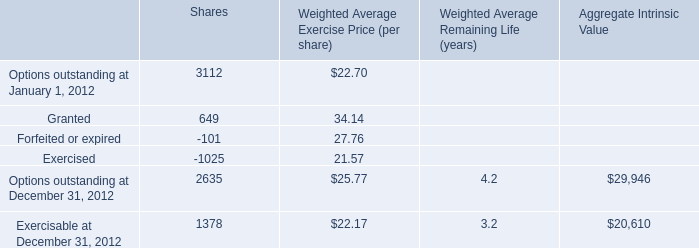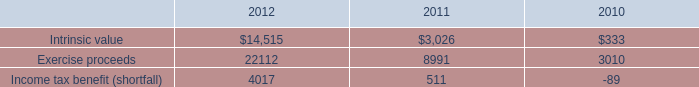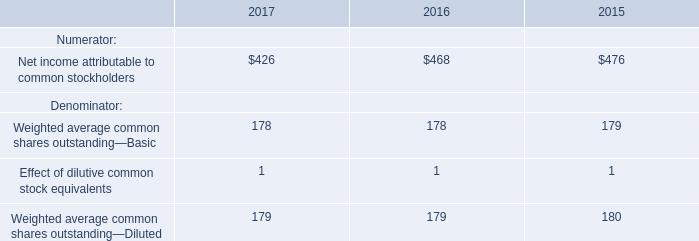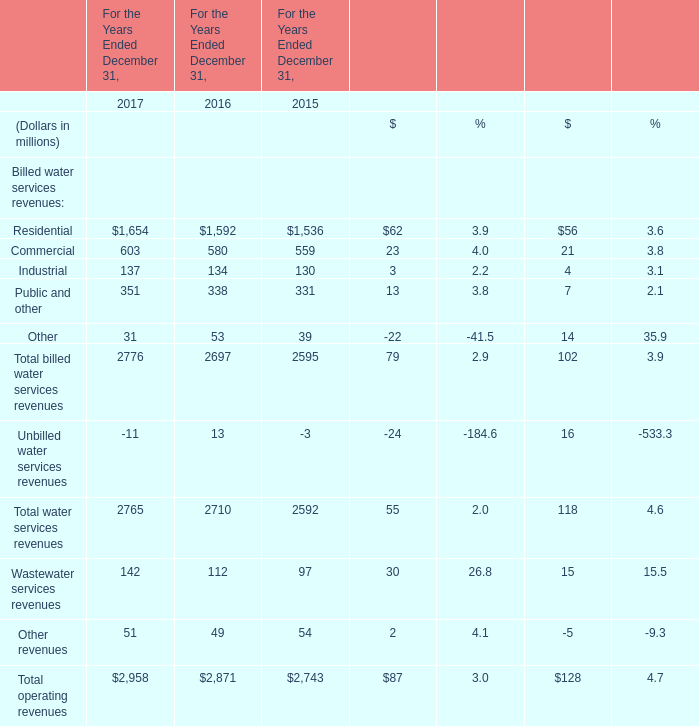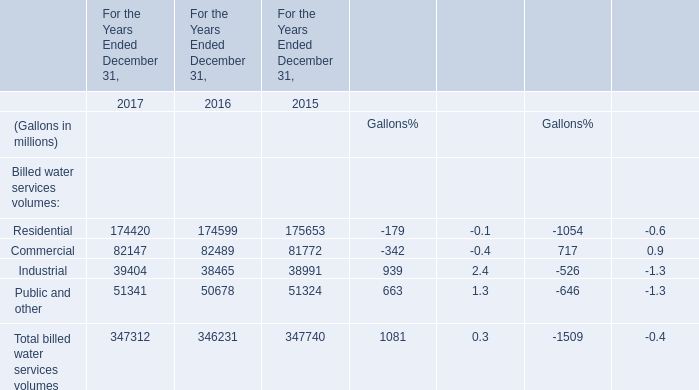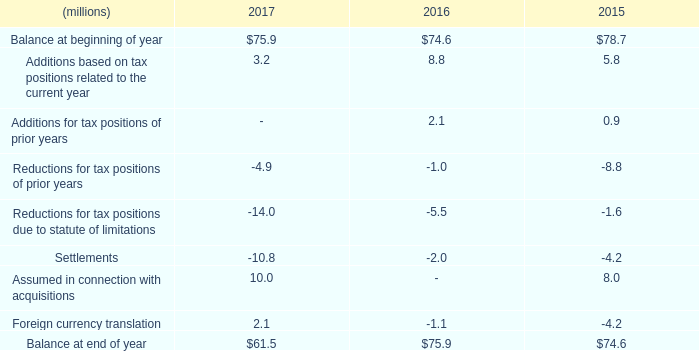What's the sum of Options outstanding at December 31, 2012 of Aggregate Intrinsic Value, Exercise proceeds of 2012, and Total billed water services volumes of For the Years Ended December 31, 2015 ? 
Computations: ((29946.0 + 22112.0) + 347740.0)
Answer: 399798.0. 